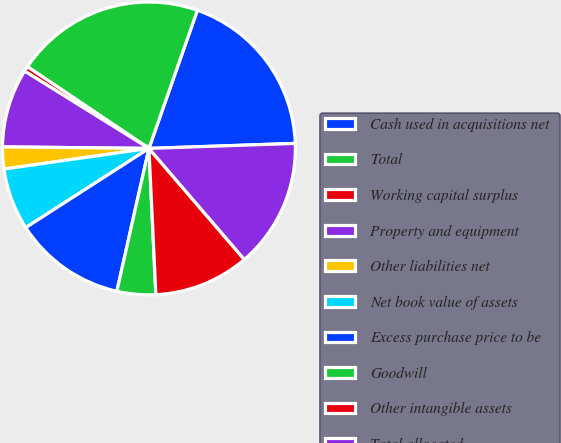Convert chart to OTSL. <chart><loc_0><loc_0><loc_500><loc_500><pie_chart><fcel>Cash used in acquisitions net<fcel>Total<fcel>Working capital surplus<fcel>Property and equipment<fcel>Other liabilities net<fcel>Net book value of assets<fcel>Excess purchase price to be<fcel>Goodwill<fcel>Other intangible assets<fcel>Total allocated<nl><fcel>19.09%<fcel>20.94%<fcel>0.57%<fcel>8.69%<fcel>2.42%<fcel>6.84%<fcel>12.39%<fcel>4.27%<fcel>10.54%<fcel>14.25%<nl></chart> 